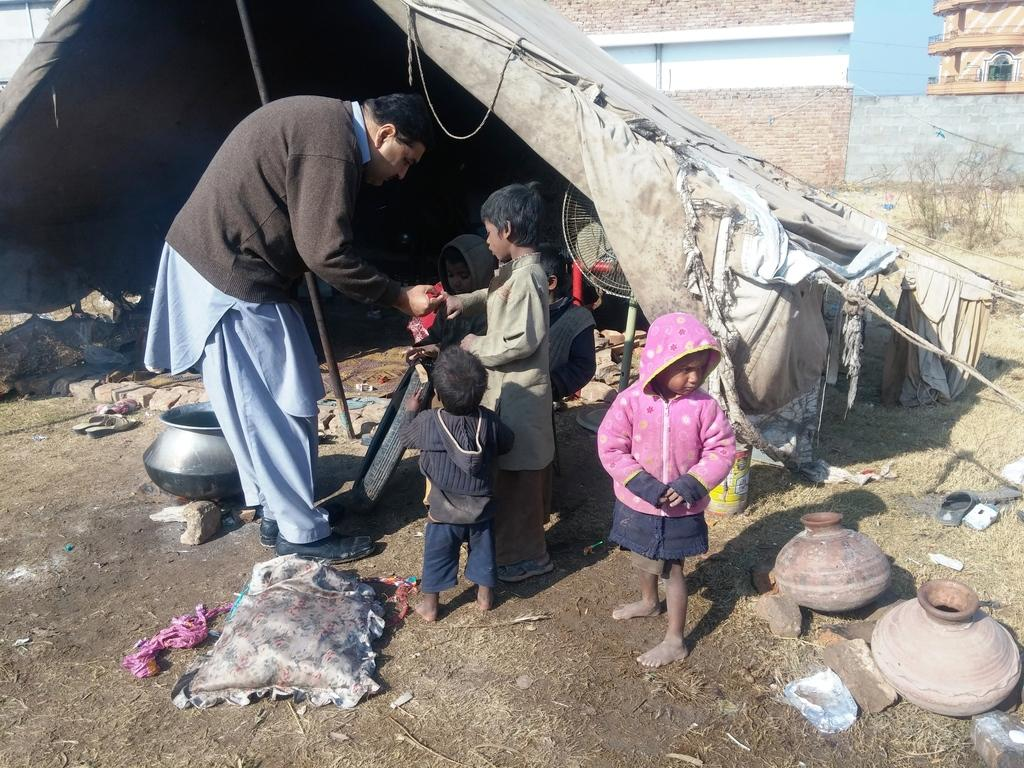What are the main subjects in the image? There are persons standing in the center of the image. What can be seen in the background of the image? There is a tent and a building in the background of the image. What objects are on the ground in the image? There are pots on the ground in the image. What type of vegetation is present on the ground in the image? There is dry grass on the ground in the image. What is the purpose of the spoon in the image? There is no spoon present in the image. Can you hear the persons in the image crying? There is no indication in the image that the persons are crying, and no sound can be heard from a still image. 